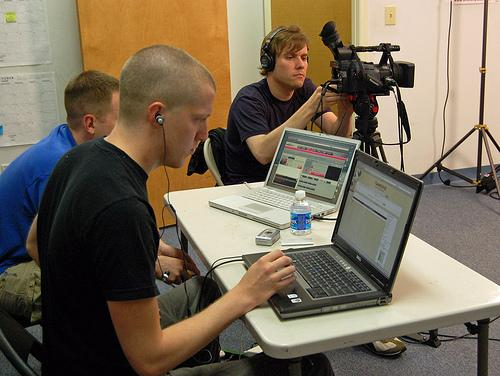Which one is doing silent work? middle 